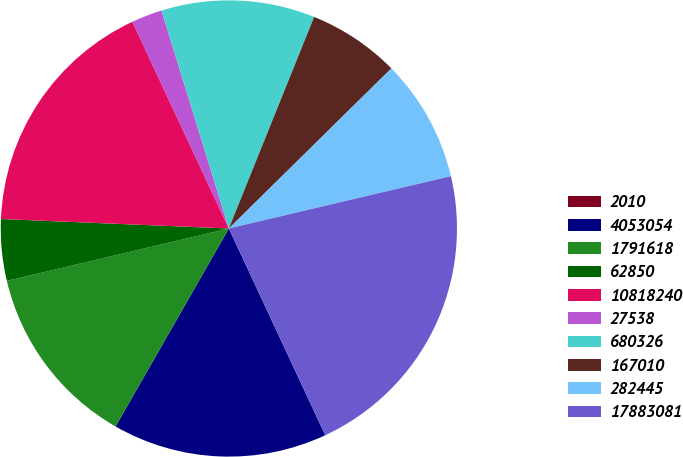Convert chart. <chart><loc_0><loc_0><loc_500><loc_500><pie_chart><fcel>2010<fcel>4053054<fcel>1791618<fcel>62850<fcel>10818240<fcel>27538<fcel>680326<fcel>167010<fcel>282445<fcel>17883081<nl><fcel>0.0%<fcel>15.22%<fcel>13.04%<fcel>4.35%<fcel>17.39%<fcel>2.18%<fcel>10.87%<fcel>6.52%<fcel>8.7%<fcel>21.74%<nl></chart> 